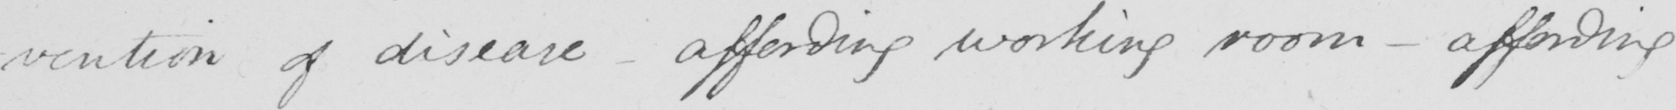Transcribe the text shown in this historical manuscript line. -vention of disease  _  affording working room  _  affording 